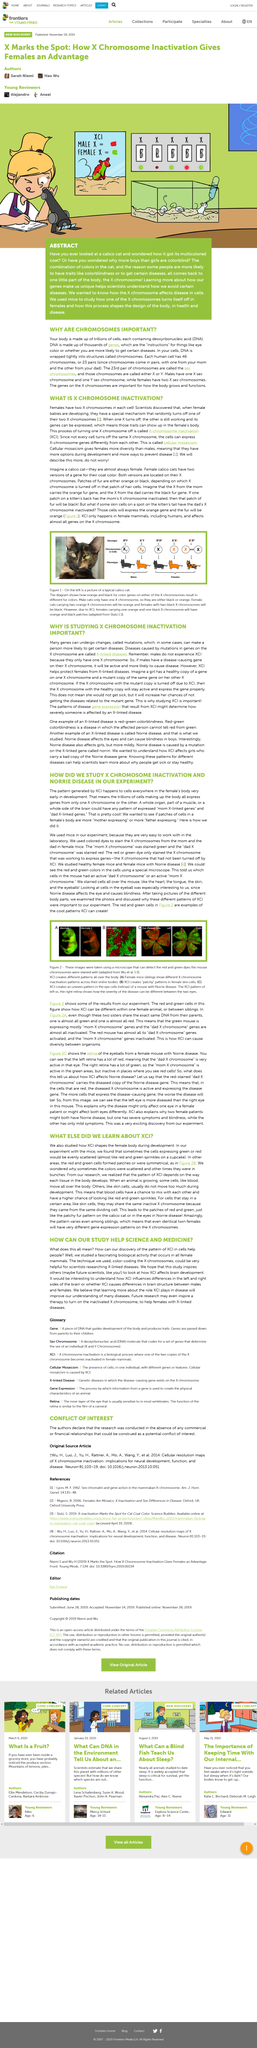Point out several critical features in this image. In our experiment with mice, we observed that the cells expressing green or red were sometimes evenly scattered throughout the organisms. The pattern of X-chromosome inactivation (XCI) is determined by the way each tissue in the body develops. Mice were used as test subjects in the research. The examination revealed that the "mom X chromosome" was not stained red, as expected, but instead was stained green. In Figure 2 of Image B, the female skin cells exhibit a patchy pattern. 